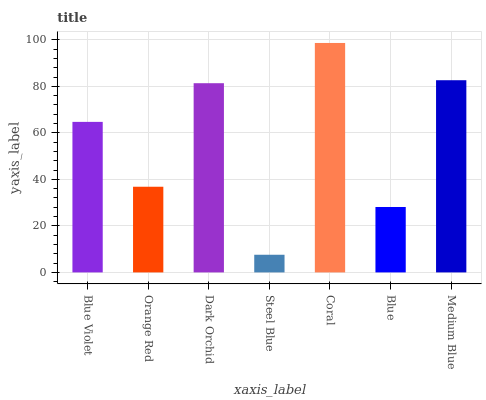Is Steel Blue the minimum?
Answer yes or no. Yes. Is Coral the maximum?
Answer yes or no. Yes. Is Orange Red the minimum?
Answer yes or no. No. Is Orange Red the maximum?
Answer yes or no. No. Is Blue Violet greater than Orange Red?
Answer yes or no. Yes. Is Orange Red less than Blue Violet?
Answer yes or no. Yes. Is Orange Red greater than Blue Violet?
Answer yes or no. No. Is Blue Violet less than Orange Red?
Answer yes or no. No. Is Blue Violet the high median?
Answer yes or no. Yes. Is Blue Violet the low median?
Answer yes or no. Yes. Is Coral the high median?
Answer yes or no. No. Is Orange Red the low median?
Answer yes or no. No. 